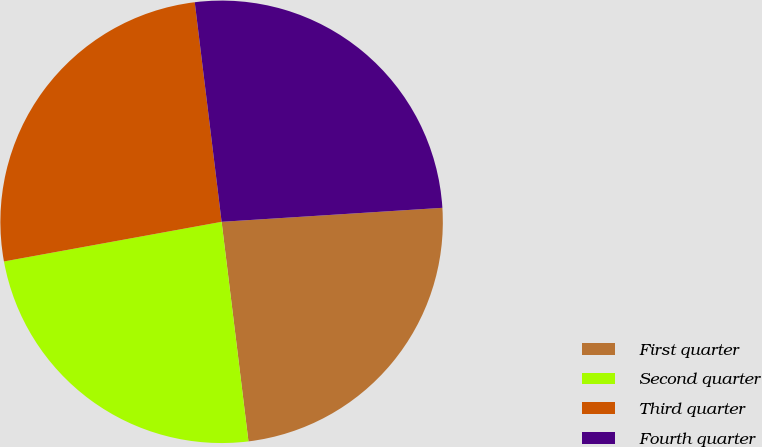Convert chart. <chart><loc_0><loc_0><loc_500><loc_500><pie_chart><fcel>First quarter<fcel>Second quarter<fcel>Third quarter<fcel>Fourth quarter<nl><fcel>24.07%<fcel>24.07%<fcel>25.93%<fcel>25.93%<nl></chart> 